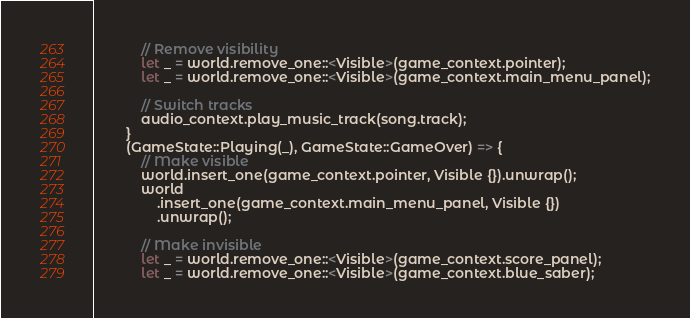<code> <loc_0><loc_0><loc_500><loc_500><_Rust_>            // Remove visibility
            let _ = world.remove_one::<Visible>(game_context.pointer);
            let _ = world.remove_one::<Visible>(game_context.main_menu_panel);

            // Switch tracks
            audio_context.play_music_track(song.track);
        }
        (GameState::Playing(_), GameState::GameOver) => {
            // Make visible
            world.insert_one(game_context.pointer, Visible {}).unwrap();
            world
                .insert_one(game_context.main_menu_panel, Visible {})
                .unwrap();

            // Make invisible
            let _ = world.remove_one::<Visible>(game_context.score_panel);
            let _ = world.remove_one::<Visible>(game_context.blue_saber);</code> 